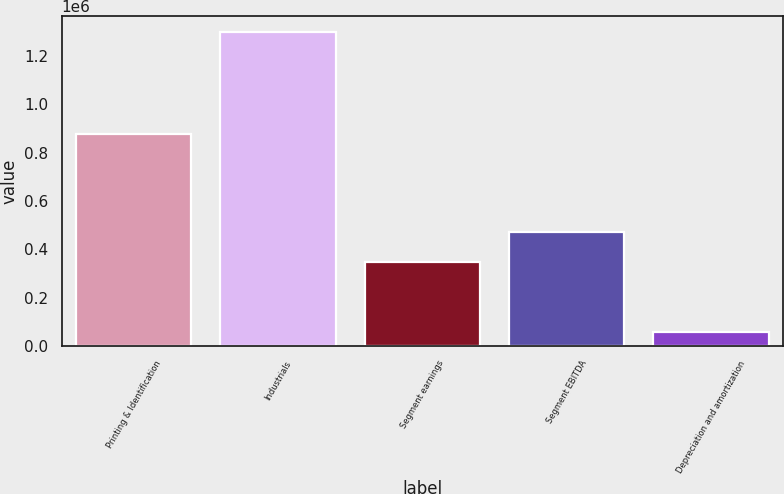Convert chart. <chart><loc_0><loc_0><loc_500><loc_500><bar_chart><fcel>Printing & Identification<fcel>Industrials<fcel>Segment earnings<fcel>Segment EBITDA<fcel>Depreciation and amortization<nl><fcel>877875<fcel>1.3001e+06<fcel>347497<fcel>471601<fcel>59058<nl></chart> 